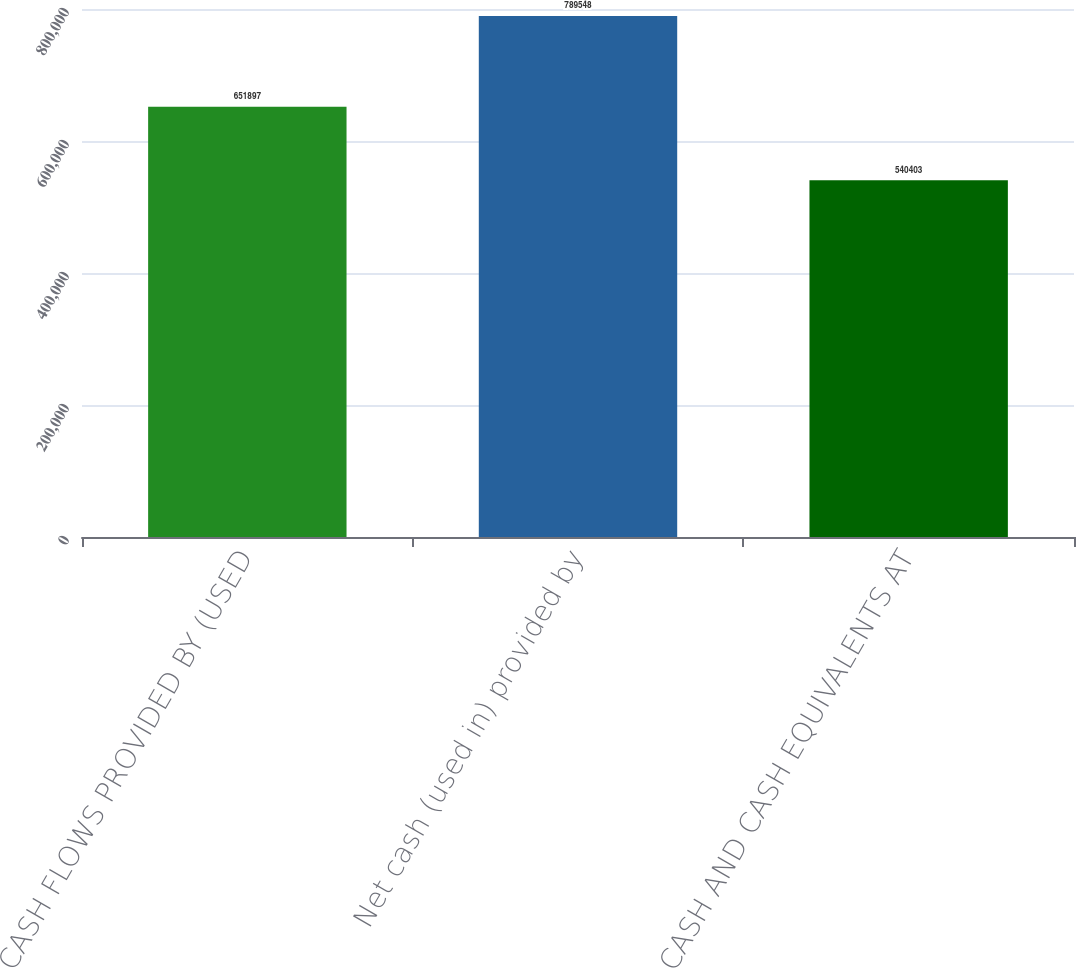<chart> <loc_0><loc_0><loc_500><loc_500><bar_chart><fcel>CASH FLOWS PROVIDED BY (USED<fcel>Net cash (used in) provided by<fcel>CASH AND CASH EQUIVALENTS AT<nl><fcel>651897<fcel>789548<fcel>540403<nl></chart> 